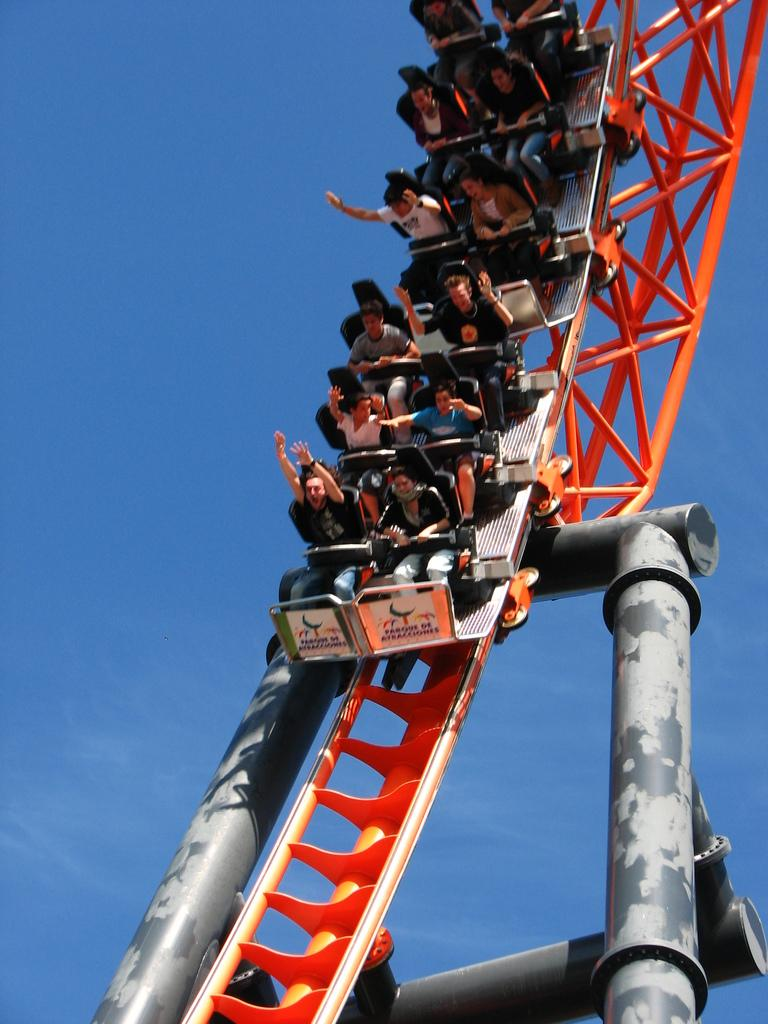What is the main subject of the picture? The main subject of the picture is a roller coaster. Are there any people on the roller coaster? Yes, there are people sitting on the roller coaster. What can be seen in the background of the picture? The sky is visible in the background of the picture. Can you tell me how many mothers are standing next to the roller coaster in the image? There is no mention of a mother or any person standing next to the roller coaster in the image. Are there any giants visible in the image? There are no giants present in the image; it features a roller coaster with people sitting on it. 